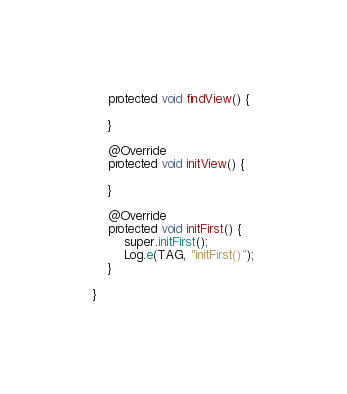<code> <loc_0><loc_0><loc_500><loc_500><_Java_>    protected void findView() {

    }

    @Override
    protected void initView() {

    }

    @Override
    protected void initFirst() {
        super.initFirst();
        Log.e(TAG, "initFirst()");
    }

}
</code> 